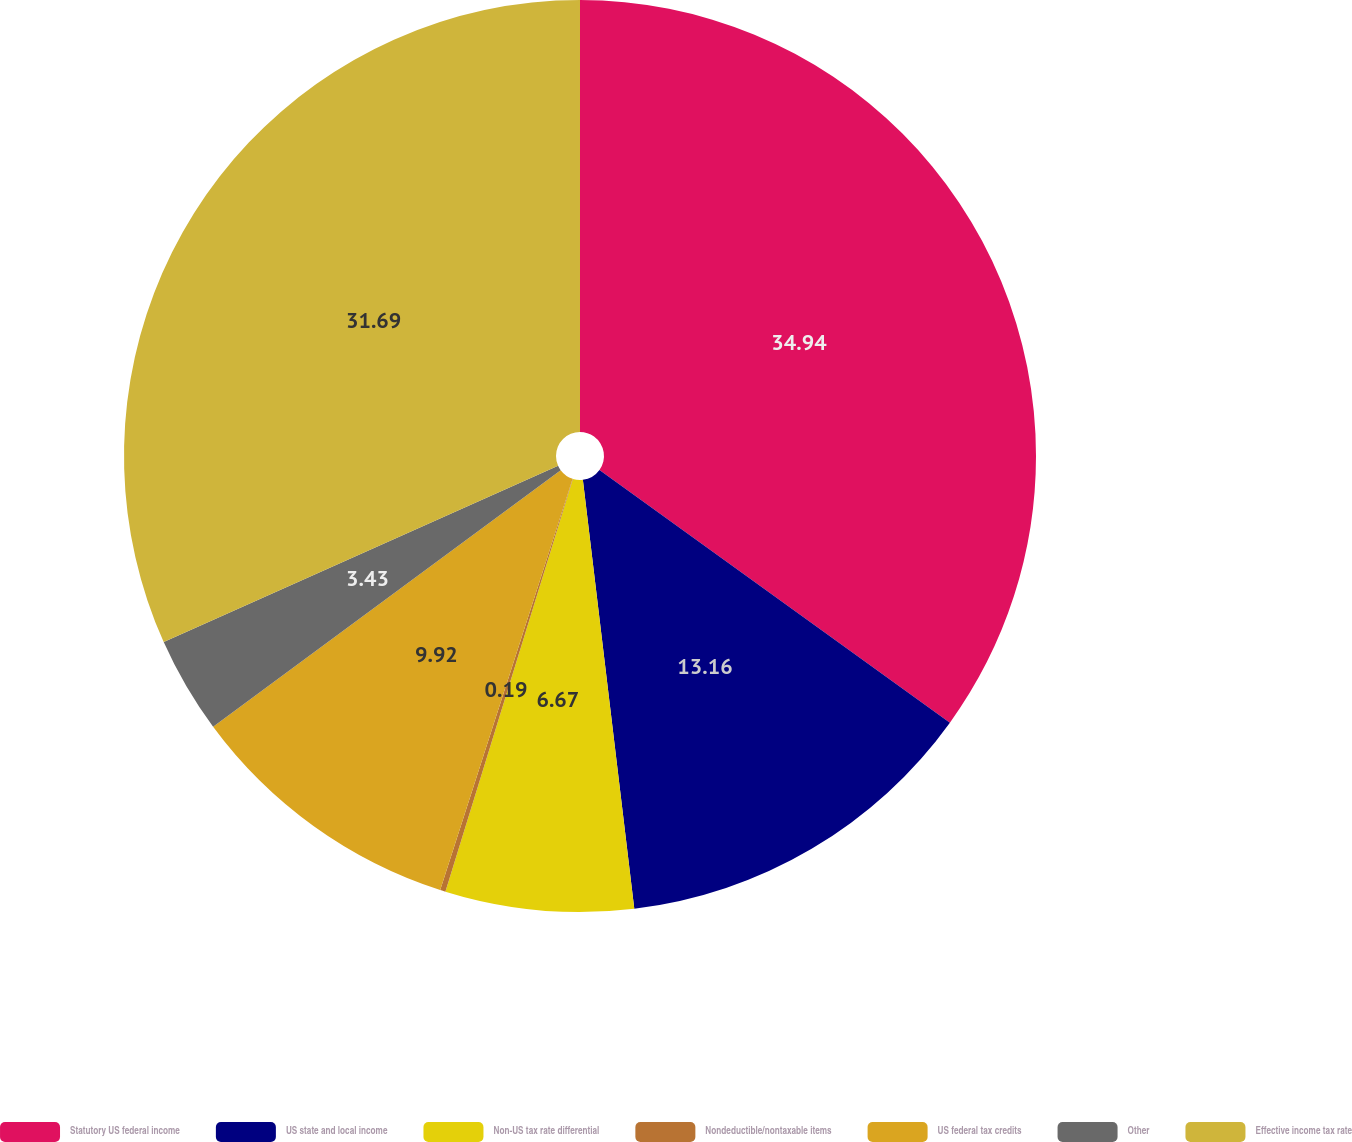<chart> <loc_0><loc_0><loc_500><loc_500><pie_chart><fcel>Statutory US federal income<fcel>US state and local income<fcel>Non-US tax rate differential<fcel>Nondeductible/nontaxable items<fcel>US federal tax credits<fcel>Other<fcel>Effective income tax rate<nl><fcel>34.94%<fcel>13.16%<fcel>6.67%<fcel>0.19%<fcel>9.92%<fcel>3.43%<fcel>31.69%<nl></chart> 